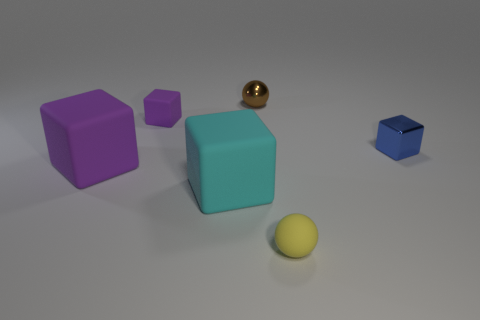The small ball behind the shiny thing on the right side of the tiny metal thing that is left of the tiny yellow rubber sphere is made of what material? metal 